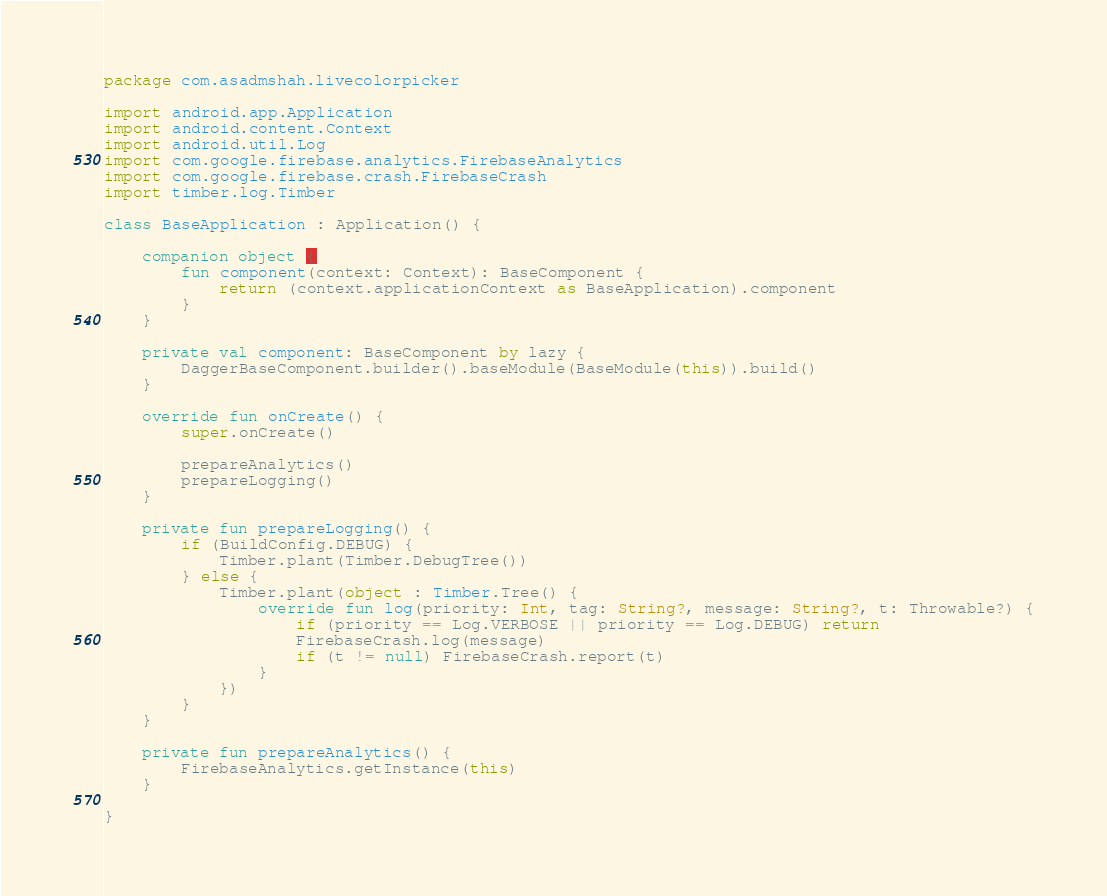Convert code to text. <code><loc_0><loc_0><loc_500><loc_500><_Kotlin_>package com.asadmshah.livecolorpicker

import android.app.Application
import android.content.Context
import android.util.Log
import com.google.firebase.analytics.FirebaseAnalytics
import com.google.firebase.crash.FirebaseCrash
import timber.log.Timber

class BaseApplication : Application() {

    companion object {
        fun component(context: Context): BaseComponent {
            return (context.applicationContext as BaseApplication).component
        }
    }

    private val component: BaseComponent by lazy {
        DaggerBaseComponent.builder().baseModule(BaseModule(this)).build()
    }

    override fun onCreate() {
        super.onCreate()

        prepareAnalytics()
        prepareLogging()
    }

    private fun prepareLogging() {
        if (BuildConfig.DEBUG) {
            Timber.plant(Timber.DebugTree())
        } else {
            Timber.plant(object : Timber.Tree() {
                override fun log(priority: Int, tag: String?, message: String?, t: Throwable?) {
                    if (priority == Log.VERBOSE || priority == Log.DEBUG) return
                    FirebaseCrash.log(message)
                    if (t != null) FirebaseCrash.report(t)
                }
            })
        }
    }

    private fun prepareAnalytics() {
        FirebaseAnalytics.getInstance(this)
    }

}</code> 